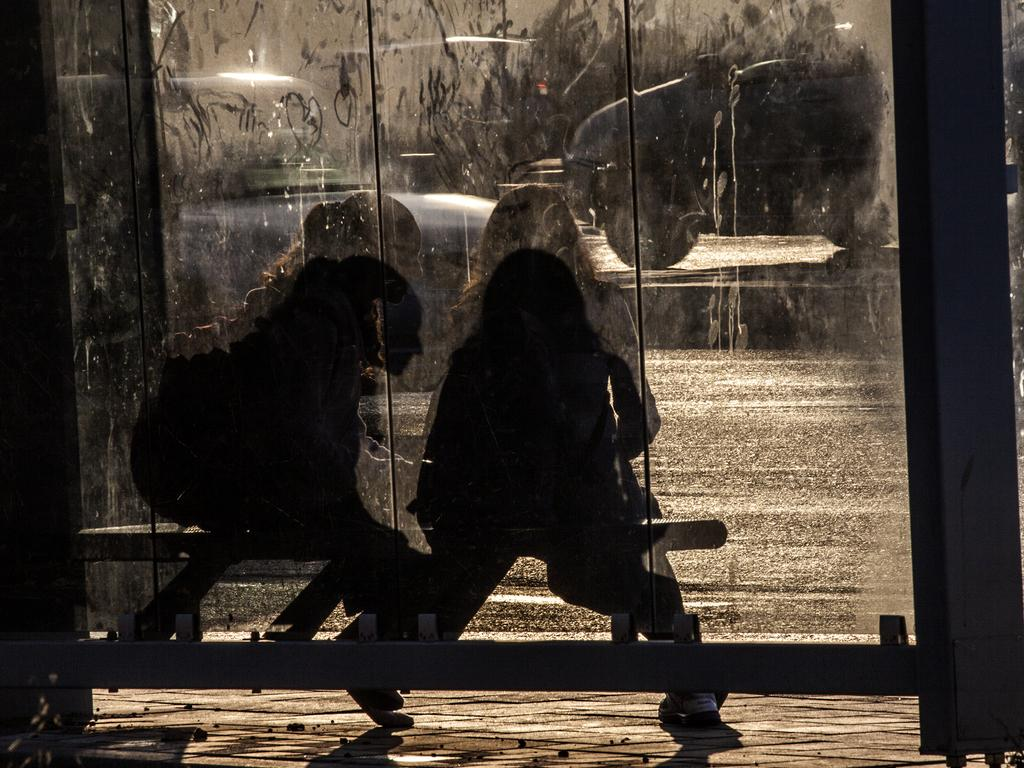Who or what can be seen in the image? There are people in the image. What material is present in the image? There is glass visible in the image. What else can be seen in the image besides people and glass? There are vehicles in the image. What type of yoke is being used by the people in the image? There is no yoke present in the image. What type of school can be seen in the image? There is no school present in the image. 